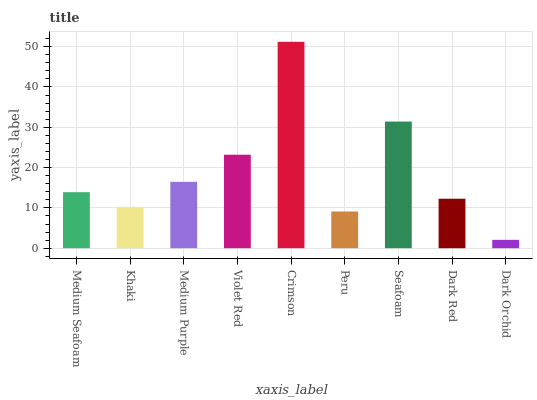Is Khaki the minimum?
Answer yes or no. No. Is Khaki the maximum?
Answer yes or no. No. Is Medium Seafoam greater than Khaki?
Answer yes or no. Yes. Is Khaki less than Medium Seafoam?
Answer yes or no. Yes. Is Khaki greater than Medium Seafoam?
Answer yes or no. No. Is Medium Seafoam less than Khaki?
Answer yes or no. No. Is Medium Seafoam the high median?
Answer yes or no. Yes. Is Medium Seafoam the low median?
Answer yes or no. Yes. Is Dark Red the high median?
Answer yes or no. No. Is Medium Purple the low median?
Answer yes or no. No. 